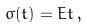Convert formula to latex. <formula><loc_0><loc_0><loc_500><loc_500>\sigma ( t ) = E t \, ,</formula> 